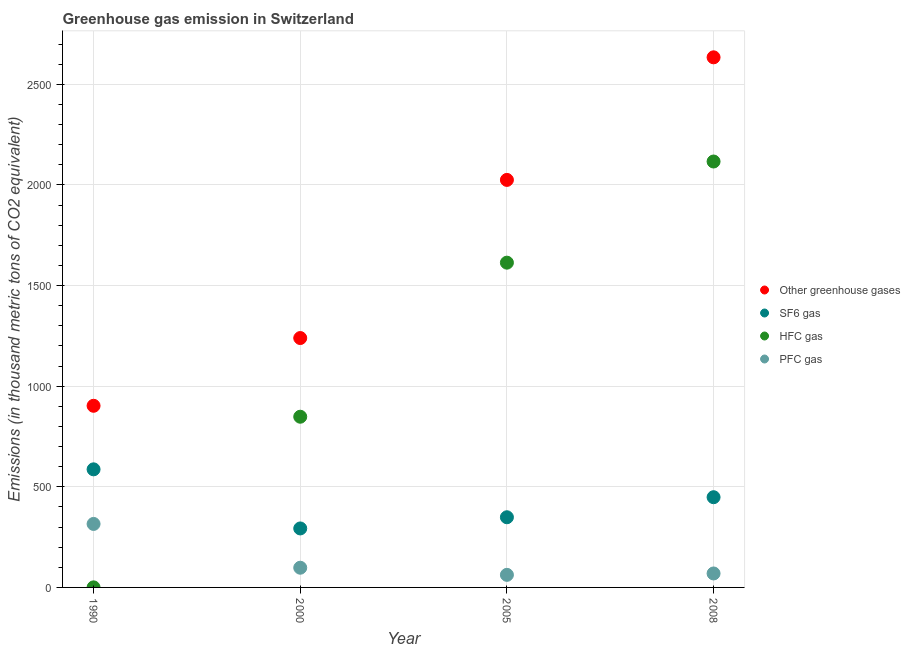Is the number of dotlines equal to the number of legend labels?
Keep it short and to the point. Yes. What is the emission of pfc gas in 1990?
Ensure brevity in your answer.  315.5. Across all years, what is the maximum emission of sf6 gas?
Your answer should be compact. 586.8. Across all years, what is the minimum emission of greenhouse gases?
Ensure brevity in your answer.  902.6. In which year was the emission of greenhouse gases minimum?
Your answer should be compact. 1990. What is the total emission of sf6 gas in the graph?
Your answer should be compact. 1676.9. What is the difference between the emission of greenhouse gases in 2000 and that in 2008?
Your answer should be compact. -1394.9. What is the difference between the emission of pfc gas in 1990 and the emission of hfc gas in 2000?
Provide a succinct answer. -532.7. What is the average emission of sf6 gas per year?
Provide a short and direct response. 419.22. In the year 2008, what is the difference between the emission of hfc gas and emission of greenhouse gases?
Ensure brevity in your answer.  -517.7. What is the ratio of the emission of pfc gas in 2005 to that in 2008?
Make the answer very short. 0.9. What is the difference between the highest and the second highest emission of pfc gas?
Provide a short and direct response. 217.6. What is the difference between the highest and the lowest emission of sf6 gas?
Your answer should be compact. 293.7. In how many years, is the emission of greenhouse gases greater than the average emission of greenhouse gases taken over all years?
Ensure brevity in your answer.  2. Is it the case that in every year, the sum of the emission of greenhouse gases and emission of sf6 gas is greater than the emission of hfc gas?
Offer a terse response. Yes. Does the emission of pfc gas monotonically increase over the years?
Offer a very short reply. No. Is the emission of pfc gas strictly greater than the emission of hfc gas over the years?
Your answer should be compact. No. How many dotlines are there?
Your response must be concise. 4. What is the difference between two consecutive major ticks on the Y-axis?
Offer a terse response. 500. Does the graph contain any zero values?
Give a very brief answer. No. Does the graph contain grids?
Provide a short and direct response. Yes. How are the legend labels stacked?
Ensure brevity in your answer.  Vertical. What is the title of the graph?
Ensure brevity in your answer.  Greenhouse gas emission in Switzerland. Does "Offering training" appear as one of the legend labels in the graph?
Offer a terse response. No. What is the label or title of the Y-axis?
Ensure brevity in your answer.  Emissions (in thousand metric tons of CO2 equivalent). What is the Emissions (in thousand metric tons of CO2 equivalent) in Other greenhouse gases in 1990?
Offer a very short reply. 902.6. What is the Emissions (in thousand metric tons of CO2 equivalent) of SF6 gas in 1990?
Ensure brevity in your answer.  586.8. What is the Emissions (in thousand metric tons of CO2 equivalent) in HFC gas in 1990?
Ensure brevity in your answer.  0.3. What is the Emissions (in thousand metric tons of CO2 equivalent) of PFC gas in 1990?
Ensure brevity in your answer.  315.5. What is the Emissions (in thousand metric tons of CO2 equivalent) of Other greenhouse gases in 2000?
Make the answer very short. 1239.2. What is the Emissions (in thousand metric tons of CO2 equivalent) of SF6 gas in 2000?
Provide a succinct answer. 293.1. What is the Emissions (in thousand metric tons of CO2 equivalent) of HFC gas in 2000?
Offer a very short reply. 848.2. What is the Emissions (in thousand metric tons of CO2 equivalent) in PFC gas in 2000?
Make the answer very short. 97.9. What is the Emissions (in thousand metric tons of CO2 equivalent) of Other greenhouse gases in 2005?
Provide a short and direct response. 2025. What is the Emissions (in thousand metric tons of CO2 equivalent) of SF6 gas in 2005?
Keep it short and to the point. 348.7. What is the Emissions (in thousand metric tons of CO2 equivalent) of HFC gas in 2005?
Keep it short and to the point. 1613.8. What is the Emissions (in thousand metric tons of CO2 equivalent) in PFC gas in 2005?
Your response must be concise. 62.5. What is the Emissions (in thousand metric tons of CO2 equivalent) of Other greenhouse gases in 2008?
Ensure brevity in your answer.  2634.1. What is the Emissions (in thousand metric tons of CO2 equivalent) of SF6 gas in 2008?
Provide a succinct answer. 448.3. What is the Emissions (in thousand metric tons of CO2 equivalent) of HFC gas in 2008?
Your answer should be very brief. 2116.4. What is the Emissions (in thousand metric tons of CO2 equivalent) of PFC gas in 2008?
Your answer should be compact. 69.4. Across all years, what is the maximum Emissions (in thousand metric tons of CO2 equivalent) of Other greenhouse gases?
Your answer should be compact. 2634.1. Across all years, what is the maximum Emissions (in thousand metric tons of CO2 equivalent) of SF6 gas?
Provide a short and direct response. 586.8. Across all years, what is the maximum Emissions (in thousand metric tons of CO2 equivalent) of HFC gas?
Your response must be concise. 2116.4. Across all years, what is the maximum Emissions (in thousand metric tons of CO2 equivalent) in PFC gas?
Ensure brevity in your answer.  315.5. Across all years, what is the minimum Emissions (in thousand metric tons of CO2 equivalent) of Other greenhouse gases?
Give a very brief answer. 902.6. Across all years, what is the minimum Emissions (in thousand metric tons of CO2 equivalent) in SF6 gas?
Offer a terse response. 293.1. Across all years, what is the minimum Emissions (in thousand metric tons of CO2 equivalent) of PFC gas?
Offer a terse response. 62.5. What is the total Emissions (in thousand metric tons of CO2 equivalent) in Other greenhouse gases in the graph?
Offer a terse response. 6800.9. What is the total Emissions (in thousand metric tons of CO2 equivalent) in SF6 gas in the graph?
Make the answer very short. 1676.9. What is the total Emissions (in thousand metric tons of CO2 equivalent) of HFC gas in the graph?
Your response must be concise. 4578.7. What is the total Emissions (in thousand metric tons of CO2 equivalent) in PFC gas in the graph?
Offer a terse response. 545.3. What is the difference between the Emissions (in thousand metric tons of CO2 equivalent) in Other greenhouse gases in 1990 and that in 2000?
Ensure brevity in your answer.  -336.6. What is the difference between the Emissions (in thousand metric tons of CO2 equivalent) in SF6 gas in 1990 and that in 2000?
Make the answer very short. 293.7. What is the difference between the Emissions (in thousand metric tons of CO2 equivalent) in HFC gas in 1990 and that in 2000?
Provide a succinct answer. -847.9. What is the difference between the Emissions (in thousand metric tons of CO2 equivalent) of PFC gas in 1990 and that in 2000?
Offer a very short reply. 217.6. What is the difference between the Emissions (in thousand metric tons of CO2 equivalent) in Other greenhouse gases in 1990 and that in 2005?
Keep it short and to the point. -1122.4. What is the difference between the Emissions (in thousand metric tons of CO2 equivalent) of SF6 gas in 1990 and that in 2005?
Ensure brevity in your answer.  238.1. What is the difference between the Emissions (in thousand metric tons of CO2 equivalent) in HFC gas in 1990 and that in 2005?
Keep it short and to the point. -1613.5. What is the difference between the Emissions (in thousand metric tons of CO2 equivalent) of PFC gas in 1990 and that in 2005?
Make the answer very short. 253. What is the difference between the Emissions (in thousand metric tons of CO2 equivalent) of Other greenhouse gases in 1990 and that in 2008?
Give a very brief answer. -1731.5. What is the difference between the Emissions (in thousand metric tons of CO2 equivalent) in SF6 gas in 1990 and that in 2008?
Ensure brevity in your answer.  138.5. What is the difference between the Emissions (in thousand metric tons of CO2 equivalent) in HFC gas in 1990 and that in 2008?
Provide a short and direct response. -2116.1. What is the difference between the Emissions (in thousand metric tons of CO2 equivalent) of PFC gas in 1990 and that in 2008?
Ensure brevity in your answer.  246.1. What is the difference between the Emissions (in thousand metric tons of CO2 equivalent) of Other greenhouse gases in 2000 and that in 2005?
Offer a very short reply. -785.8. What is the difference between the Emissions (in thousand metric tons of CO2 equivalent) of SF6 gas in 2000 and that in 2005?
Keep it short and to the point. -55.6. What is the difference between the Emissions (in thousand metric tons of CO2 equivalent) in HFC gas in 2000 and that in 2005?
Offer a very short reply. -765.6. What is the difference between the Emissions (in thousand metric tons of CO2 equivalent) in PFC gas in 2000 and that in 2005?
Your answer should be very brief. 35.4. What is the difference between the Emissions (in thousand metric tons of CO2 equivalent) in Other greenhouse gases in 2000 and that in 2008?
Keep it short and to the point. -1394.9. What is the difference between the Emissions (in thousand metric tons of CO2 equivalent) of SF6 gas in 2000 and that in 2008?
Make the answer very short. -155.2. What is the difference between the Emissions (in thousand metric tons of CO2 equivalent) of HFC gas in 2000 and that in 2008?
Your response must be concise. -1268.2. What is the difference between the Emissions (in thousand metric tons of CO2 equivalent) in Other greenhouse gases in 2005 and that in 2008?
Your answer should be very brief. -609.1. What is the difference between the Emissions (in thousand metric tons of CO2 equivalent) of SF6 gas in 2005 and that in 2008?
Keep it short and to the point. -99.6. What is the difference between the Emissions (in thousand metric tons of CO2 equivalent) of HFC gas in 2005 and that in 2008?
Provide a short and direct response. -502.6. What is the difference between the Emissions (in thousand metric tons of CO2 equivalent) in Other greenhouse gases in 1990 and the Emissions (in thousand metric tons of CO2 equivalent) in SF6 gas in 2000?
Offer a very short reply. 609.5. What is the difference between the Emissions (in thousand metric tons of CO2 equivalent) in Other greenhouse gases in 1990 and the Emissions (in thousand metric tons of CO2 equivalent) in HFC gas in 2000?
Your answer should be very brief. 54.4. What is the difference between the Emissions (in thousand metric tons of CO2 equivalent) of Other greenhouse gases in 1990 and the Emissions (in thousand metric tons of CO2 equivalent) of PFC gas in 2000?
Ensure brevity in your answer.  804.7. What is the difference between the Emissions (in thousand metric tons of CO2 equivalent) in SF6 gas in 1990 and the Emissions (in thousand metric tons of CO2 equivalent) in HFC gas in 2000?
Your answer should be compact. -261.4. What is the difference between the Emissions (in thousand metric tons of CO2 equivalent) in SF6 gas in 1990 and the Emissions (in thousand metric tons of CO2 equivalent) in PFC gas in 2000?
Offer a very short reply. 488.9. What is the difference between the Emissions (in thousand metric tons of CO2 equivalent) of HFC gas in 1990 and the Emissions (in thousand metric tons of CO2 equivalent) of PFC gas in 2000?
Your response must be concise. -97.6. What is the difference between the Emissions (in thousand metric tons of CO2 equivalent) of Other greenhouse gases in 1990 and the Emissions (in thousand metric tons of CO2 equivalent) of SF6 gas in 2005?
Ensure brevity in your answer.  553.9. What is the difference between the Emissions (in thousand metric tons of CO2 equivalent) in Other greenhouse gases in 1990 and the Emissions (in thousand metric tons of CO2 equivalent) in HFC gas in 2005?
Keep it short and to the point. -711.2. What is the difference between the Emissions (in thousand metric tons of CO2 equivalent) in Other greenhouse gases in 1990 and the Emissions (in thousand metric tons of CO2 equivalent) in PFC gas in 2005?
Make the answer very short. 840.1. What is the difference between the Emissions (in thousand metric tons of CO2 equivalent) in SF6 gas in 1990 and the Emissions (in thousand metric tons of CO2 equivalent) in HFC gas in 2005?
Provide a succinct answer. -1027. What is the difference between the Emissions (in thousand metric tons of CO2 equivalent) in SF6 gas in 1990 and the Emissions (in thousand metric tons of CO2 equivalent) in PFC gas in 2005?
Provide a succinct answer. 524.3. What is the difference between the Emissions (in thousand metric tons of CO2 equivalent) in HFC gas in 1990 and the Emissions (in thousand metric tons of CO2 equivalent) in PFC gas in 2005?
Provide a short and direct response. -62.2. What is the difference between the Emissions (in thousand metric tons of CO2 equivalent) of Other greenhouse gases in 1990 and the Emissions (in thousand metric tons of CO2 equivalent) of SF6 gas in 2008?
Provide a short and direct response. 454.3. What is the difference between the Emissions (in thousand metric tons of CO2 equivalent) in Other greenhouse gases in 1990 and the Emissions (in thousand metric tons of CO2 equivalent) in HFC gas in 2008?
Give a very brief answer. -1213.8. What is the difference between the Emissions (in thousand metric tons of CO2 equivalent) of Other greenhouse gases in 1990 and the Emissions (in thousand metric tons of CO2 equivalent) of PFC gas in 2008?
Keep it short and to the point. 833.2. What is the difference between the Emissions (in thousand metric tons of CO2 equivalent) in SF6 gas in 1990 and the Emissions (in thousand metric tons of CO2 equivalent) in HFC gas in 2008?
Ensure brevity in your answer.  -1529.6. What is the difference between the Emissions (in thousand metric tons of CO2 equivalent) in SF6 gas in 1990 and the Emissions (in thousand metric tons of CO2 equivalent) in PFC gas in 2008?
Offer a terse response. 517.4. What is the difference between the Emissions (in thousand metric tons of CO2 equivalent) of HFC gas in 1990 and the Emissions (in thousand metric tons of CO2 equivalent) of PFC gas in 2008?
Make the answer very short. -69.1. What is the difference between the Emissions (in thousand metric tons of CO2 equivalent) of Other greenhouse gases in 2000 and the Emissions (in thousand metric tons of CO2 equivalent) of SF6 gas in 2005?
Your answer should be compact. 890.5. What is the difference between the Emissions (in thousand metric tons of CO2 equivalent) of Other greenhouse gases in 2000 and the Emissions (in thousand metric tons of CO2 equivalent) of HFC gas in 2005?
Offer a terse response. -374.6. What is the difference between the Emissions (in thousand metric tons of CO2 equivalent) in Other greenhouse gases in 2000 and the Emissions (in thousand metric tons of CO2 equivalent) in PFC gas in 2005?
Keep it short and to the point. 1176.7. What is the difference between the Emissions (in thousand metric tons of CO2 equivalent) in SF6 gas in 2000 and the Emissions (in thousand metric tons of CO2 equivalent) in HFC gas in 2005?
Your answer should be compact. -1320.7. What is the difference between the Emissions (in thousand metric tons of CO2 equivalent) of SF6 gas in 2000 and the Emissions (in thousand metric tons of CO2 equivalent) of PFC gas in 2005?
Your answer should be very brief. 230.6. What is the difference between the Emissions (in thousand metric tons of CO2 equivalent) of HFC gas in 2000 and the Emissions (in thousand metric tons of CO2 equivalent) of PFC gas in 2005?
Your answer should be very brief. 785.7. What is the difference between the Emissions (in thousand metric tons of CO2 equivalent) in Other greenhouse gases in 2000 and the Emissions (in thousand metric tons of CO2 equivalent) in SF6 gas in 2008?
Make the answer very short. 790.9. What is the difference between the Emissions (in thousand metric tons of CO2 equivalent) of Other greenhouse gases in 2000 and the Emissions (in thousand metric tons of CO2 equivalent) of HFC gas in 2008?
Give a very brief answer. -877.2. What is the difference between the Emissions (in thousand metric tons of CO2 equivalent) of Other greenhouse gases in 2000 and the Emissions (in thousand metric tons of CO2 equivalent) of PFC gas in 2008?
Offer a very short reply. 1169.8. What is the difference between the Emissions (in thousand metric tons of CO2 equivalent) of SF6 gas in 2000 and the Emissions (in thousand metric tons of CO2 equivalent) of HFC gas in 2008?
Ensure brevity in your answer.  -1823.3. What is the difference between the Emissions (in thousand metric tons of CO2 equivalent) in SF6 gas in 2000 and the Emissions (in thousand metric tons of CO2 equivalent) in PFC gas in 2008?
Your response must be concise. 223.7. What is the difference between the Emissions (in thousand metric tons of CO2 equivalent) of HFC gas in 2000 and the Emissions (in thousand metric tons of CO2 equivalent) of PFC gas in 2008?
Offer a very short reply. 778.8. What is the difference between the Emissions (in thousand metric tons of CO2 equivalent) of Other greenhouse gases in 2005 and the Emissions (in thousand metric tons of CO2 equivalent) of SF6 gas in 2008?
Your response must be concise. 1576.7. What is the difference between the Emissions (in thousand metric tons of CO2 equivalent) of Other greenhouse gases in 2005 and the Emissions (in thousand metric tons of CO2 equivalent) of HFC gas in 2008?
Your answer should be compact. -91.4. What is the difference between the Emissions (in thousand metric tons of CO2 equivalent) of Other greenhouse gases in 2005 and the Emissions (in thousand metric tons of CO2 equivalent) of PFC gas in 2008?
Give a very brief answer. 1955.6. What is the difference between the Emissions (in thousand metric tons of CO2 equivalent) of SF6 gas in 2005 and the Emissions (in thousand metric tons of CO2 equivalent) of HFC gas in 2008?
Provide a short and direct response. -1767.7. What is the difference between the Emissions (in thousand metric tons of CO2 equivalent) in SF6 gas in 2005 and the Emissions (in thousand metric tons of CO2 equivalent) in PFC gas in 2008?
Keep it short and to the point. 279.3. What is the difference between the Emissions (in thousand metric tons of CO2 equivalent) in HFC gas in 2005 and the Emissions (in thousand metric tons of CO2 equivalent) in PFC gas in 2008?
Provide a succinct answer. 1544.4. What is the average Emissions (in thousand metric tons of CO2 equivalent) of Other greenhouse gases per year?
Your response must be concise. 1700.22. What is the average Emissions (in thousand metric tons of CO2 equivalent) of SF6 gas per year?
Offer a terse response. 419.23. What is the average Emissions (in thousand metric tons of CO2 equivalent) in HFC gas per year?
Provide a short and direct response. 1144.67. What is the average Emissions (in thousand metric tons of CO2 equivalent) of PFC gas per year?
Offer a very short reply. 136.32. In the year 1990, what is the difference between the Emissions (in thousand metric tons of CO2 equivalent) of Other greenhouse gases and Emissions (in thousand metric tons of CO2 equivalent) of SF6 gas?
Your answer should be compact. 315.8. In the year 1990, what is the difference between the Emissions (in thousand metric tons of CO2 equivalent) in Other greenhouse gases and Emissions (in thousand metric tons of CO2 equivalent) in HFC gas?
Your response must be concise. 902.3. In the year 1990, what is the difference between the Emissions (in thousand metric tons of CO2 equivalent) of Other greenhouse gases and Emissions (in thousand metric tons of CO2 equivalent) of PFC gas?
Offer a terse response. 587.1. In the year 1990, what is the difference between the Emissions (in thousand metric tons of CO2 equivalent) of SF6 gas and Emissions (in thousand metric tons of CO2 equivalent) of HFC gas?
Ensure brevity in your answer.  586.5. In the year 1990, what is the difference between the Emissions (in thousand metric tons of CO2 equivalent) of SF6 gas and Emissions (in thousand metric tons of CO2 equivalent) of PFC gas?
Your answer should be compact. 271.3. In the year 1990, what is the difference between the Emissions (in thousand metric tons of CO2 equivalent) of HFC gas and Emissions (in thousand metric tons of CO2 equivalent) of PFC gas?
Your answer should be compact. -315.2. In the year 2000, what is the difference between the Emissions (in thousand metric tons of CO2 equivalent) of Other greenhouse gases and Emissions (in thousand metric tons of CO2 equivalent) of SF6 gas?
Your answer should be compact. 946.1. In the year 2000, what is the difference between the Emissions (in thousand metric tons of CO2 equivalent) in Other greenhouse gases and Emissions (in thousand metric tons of CO2 equivalent) in HFC gas?
Your answer should be very brief. 391. In the year 2000, what is the difference between the Emissions (in thousand metric tons of CO2 equivalent) in Other greenhouse gases and Emissions (in thousand metric tons of CO2 equivalent) in PFC gas?
Offer a terse response. 1141.3. In the year 2000, what is the difference between the Emissions (in thousand metric tons of CO2 equivalent) in SF6 gas and Emissions (in thousand metric tons of CO2 equivalent) in HFC gas?
Offer a terse response. -555.1. In the year 2000, what is the difference between the Emissions (in thousand metric tons of CO2 equivalent) in SF6 gas and Emissions (in thousand metric tons of CO2 equivalent) in PFC gas?
Your answer should be very brief. 195.2. In the year 2000, what is the difference between the Emissions (in thousand metric tons of CO2 equivalent) in HFC gas and Emissions (in thousand metric tons of CO2 equivalent) in PFC gas?
Provide a short and direct response. 750.3. In the year 2005, what is the difference between the Emissions (in thousand metric tons of CO2 equivalent) of Other greenhouse gases and Emissions (in thousand metric tons of CO2 equivalent) of SF6 gas?
Make the answer very short. 1676.3. In the year 2005, what is the difference between the Emissions (in thousand metric tons of CO2 equivalent) in Other greenhouse gases and Emissions (in thousand metric tons of CO2 equivalent) in HFC gas?
Your response must be concise. 411.2. In the year 2005, what is the difference between the Emissions (in thousand metric tons of CO2 equivalent) in Other greenhouse gases and Emissions (in thousand metric tons of CO2 equivalent) in PFC gas?
Provide a succinct answer. 1962.5. In the year 2005, what is the difference between the Emissions (in thousand metric tons of CO2 equivalent) in SF6 gas and Emissions (in thousand metric tons of CO2 equivalent) in HFC gas?
Provide a succinct answer. -1265.1. In the year 2005, what is the difference between the Emissions (in thousand metric tons of CO2 equivalent) in SF6 gas and Emissions (in thousand metric tons of CO2 equivalent) in PFC gas?
Offer a terse response. 286.2. In the year 2005, what is the difference between the Emissions (in thousand metric tons of CO2 equivalent) in HFC gas and Emissions (in thousand metric tons of CO2 equivalent) in PFC gas?
Your answer should be compact. 1551.3. In the year 2008, what is the difference between the Emissions (in thousand metric tons of CO2 equivalent) of Other greenhouse gases and Emissions (in thousand metric tons of CO2 equivalent) of SF6 gas?
Your response must be concise. 2185.8. In the year 2008, what is the difference between the Emissions (in thousand metric tons of CO2 equivalent) of Other greenhouse gases and Emissions (in thousand metric tons of CO2 equivalent) of HFC gas?
Make the answer very short. 517.7. In the year 2008, what is the difference between the Emissions (in thousand metric tons of CO2 equivalent) of Other greenhouse gases and Emissions (in thousand metric tons of CO2 equivalent) of PFC gas?
Keep it short and to the point. 2564.7. In the year 2008, what is the difference between the Emissions (in thousand metric tons of CO2 equivalent) of SF6 gas and Emissions (in thousand metric tons of CO2 equivalent) of HFC gas?
Offer a terse response. -1668.1. In the year 2008, what is the difference between the Emissions (in thousand metric tons of CO2 equivalent) in SF6 gas and Emissions (in thousand metric tons of CO2 equivalent) in PFC gas?
Provide a short and direct response. 378.9. In the year 2008, what is the difference between the Emissions (in thousand metric tons of CO2 equivalent) of HFC gas and Emissions (in thousand metric tons of CO2 equivalent) of PFC gas?
Make the answer very short. 2047. What is the ratio of the Emissions (in thousand metric tons of CO2 equivalent) in Other greenhouse gases in 1990 to that in 2000?
Make the answer very short. 0.73. What is the ratio of the Emissions (in thousand metric tons of CO2 equivalent) of SF6 gas in 1990 to that in 2000?
Your answer should be very brief. 2. What is the ratio of the Emissions (in thousand metric tons of CO2 equivalent) of HFC gas in 1990 to that in 2000?
Offer a terse response. 0. What is the ratio of the Emissions (in thousand metric tons of CO2 equivalent) of PFC gas in 1990 to that in 2000?
Offer a terse response. 3.22. What is the ratio of the Emissions (in thousand metric tons of CO2 equivalent) of Other greenhouse gases in 1990 to that in 2005?
Keep it short and to the point. 0.45. What is the ratio of the Emissions (in thousand metric tons of CO2 equivalent) of SF6 gas in 1990 to that in 2005?
Your answer should be compact. 1.68. What is the ratio of the Emissions (in thousand metric tons of CO2 equivalent) of HFC gas in 1990 to that in 2005?
Offer a very short reply. 0. What is the ratio of the Emissions (in thousand metric tons of CO2 equivalent) in PFC gas in 1990 to that in 2005?
Offer a very short reply. 5.05. What is the ratio of the Emissions (in thousand metric tons of CO2 equivalent) of Other greenhouse gases in 1990 to that in 2008?
Offer a very short reply. 0.34. What is the ratio of the Emissions (in thousand metric tons of CO2 equivalent) in SF6 gas in 1990 to that in 2008?
Keep it short and to the point. 1.31. What is the ratio of the Emissions (in thousand metric tons of CO2 equivalent) in HFC gas in 1990 to that in 2008?
Your answer should be compact. 0. What is the ratio of the Emissions (in thousand metric tons of CO2 equivalent) of PFC gas in 1990 to that in 2008?
Offer a terse response. 4.55. What is the ratio of the Emissions (in thousand metric tons of CO2 equivalent) of Other greenhouse gases in 2000 to that in 2005?
Provide a succinct answer. 0.61. What is the ratio of the Emissions (in thousand metric tons of CO2 equivalent) of SF6 gas in 2000 to that in 2005?
Your answer should be compact. 0.84. What is the ratio of the Emissions (in thousand metric tons of CO2 equivalent) of HFC gas in 2000 to that in 2005?
Provide a succinct answer. 0.53. What is the ratio of the Emissions (in thousand metric tons of CO2 equivalent) of PFC gas in 2000 to that in 2005?
Your answer should be compact. 1.57. What is the ratio of the Emissions (in thousand metric tons of CO2 equivalent) in Other greenhouse gases in 2000 to that in 2008?
Make the answer very short. 0.47. What is the ratio of the Emissions (in thousand metric tons of CO2 equivalent) in SF6 gas in 2000 to that in 2008?
Give a very brief answer. 0.65. What is the ratio of the Emissions (in thousand metric tons of CO2 equivalent) of HFC gas in 2000 to that in 2008?
Your response must be concise. 0.4. What is the ratio of the Emissions (in thousand metric tons of CO2 equivalent) in PFC gas in 2000 to that in 2008?
Give a very brief answer. 1.41. What is the ratio of the Emissions (in thousand metric tons of CO2 equivalent) in Other greenhouse gases in 2005 to that in 2008?
Give a very brief answer. 0.77. What is the ratio of the Emissions (in thousand metric tons of CO2 equivalent) in SF6 gas in 2005 to that in 2008?
Offer a terse response. 0.78. What is the ratio of the Emissions (in thousand metric tons of CO2 equivalent) of HFC gas in 2005 to that in 2008?
Provide a short and direct response. 0.76. What is the ratio of the Emissions (in thousand metric tons of CO2 equivalent) of PFC gas in 2005 to that in 2008?
Offer a terse response. 0.9. What is the difference between the highest and the second highest Emissions (in thousand metric tons of CO2 equivalent) in Other greenhouse gases?
Provide a succinct answer. 609.1. What is the difference between the highest and the second highest Emissions (in thousand metric tons of CO2 equivalent) of SF6 gas?
Provide a succinct answer. 138.5. What is the difference between the highest and the second highest Emissions (in thousand metric tons of CO2 equivalent) in HFC gas?
Your answer should be very brief. 502.6. What is the difference between the highest and the second highest Emissions (in thousand metric tons of CO2 equivalent) of PFC gas?
Offer a terse response. 217.6. What is the difference between the highest and the lowest Emissions (in thousand metric tons of CO2 equivalent) in Other greenhouse gases?
Provide a short and direct response. 1731.5. What is the difference between the highest and the lowest Emissions (in thousand metric tons of CO2 equivalent) in SF6 gas?
Provide a succinct answer. 293.7. What is the difference between the highest and the lowest Emissions (in thousand metric tons of CO2 equivalent) of HFC gas?
Make the answer very short. 2116.1. What is the difference between the highest and the lowest Emissions (in thousand metric tons of CO2 equivalent) in PFC gas?
Offer a terse response. 253. 